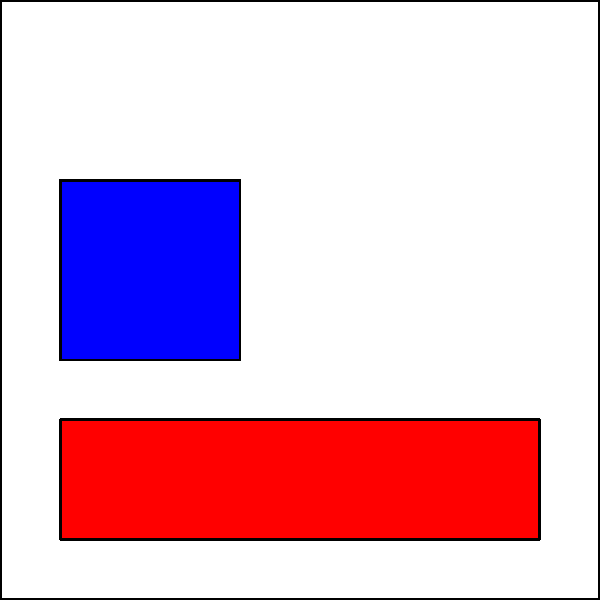As a digital marketer analyzing a website's heatmap, which area of the page appears to have the highest user engagement based on the color intensity? To answer this question, we need to understand how heatmaps work and interpret the colors in the given image:

1. Heatmaps use color to represent data intensity or frequency.
2. In website heatmaps, warmer colors (reds, oranges) typically indicate higher engagement or more clicks, while cooler colors (blues, greens) indicate lower engagement.

Analyzing the heatmap:

1. The header area (top) is colored in bright red, indicating the highest intensity.
2. The sidebar (left) is colored in blue, suggesting low engagement.
3. The main content area (right) is colored in a medium intensity, indicating moderate engagement.
4. The footer area (bottom) is colored in a warm orange, suggesting high engagement but not as high as the header.

Based on this analysis, the area with the highest color intensity, and thus the highest user engagement, is the header section at the top of the page.
Answer: Header 